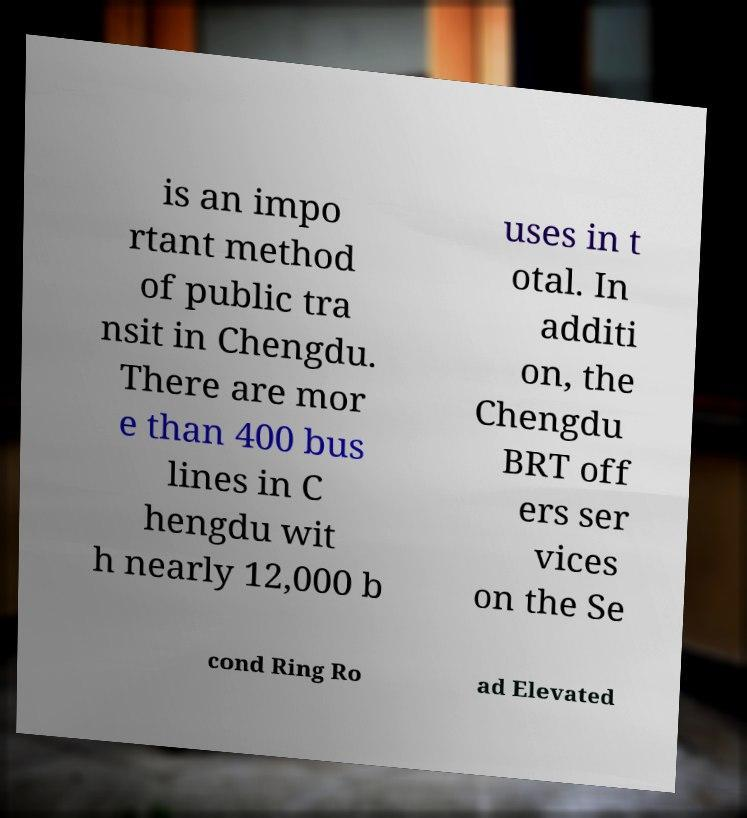Can you accurately transcribe the text from the provided image for me? is an impo rtant method of public tra nsit in Chengdu. There are mor e than 400 bus lines in C hengdu wit h nearly 12,000 b uses in t otal. In additi on, the Chengdu BRT off ers ser vices on the Se cond Ring Ro ad Elevated 